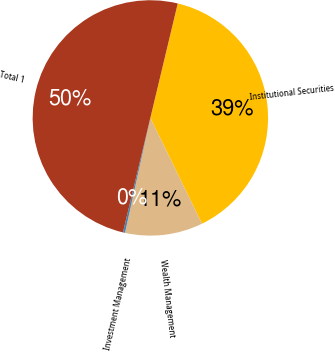Convert chart to OTSL. <chart><loc_0><loc_0><loc_500><loc_500><pie_chart><fcel>Institutional Securities<fcel>Wealth Management<fcel>Investment Management<fcel>Total 1<nl><fcel>39.04%<fcel>10.68%<fcel>0.28%<fcel>50.0%<nl></chart> 